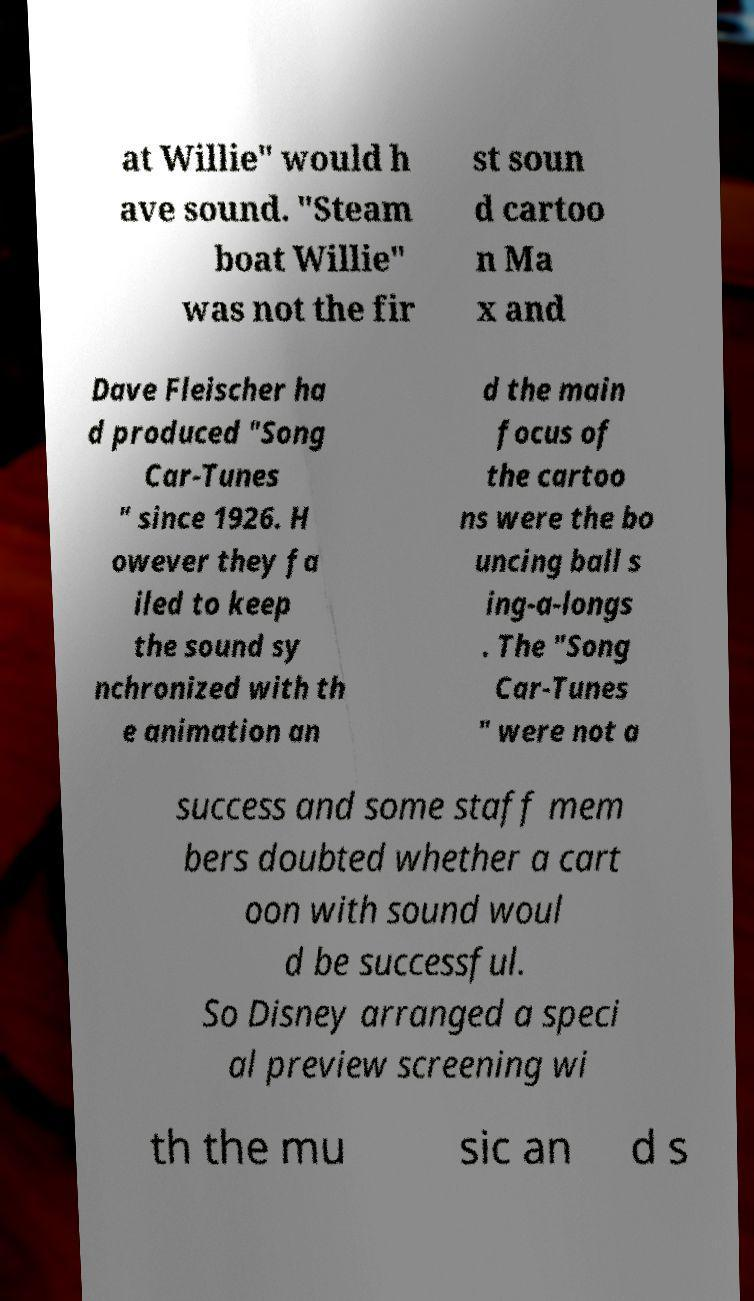Could you extract and type out the text from this image? at Willie" would h ave sound. "Steam boat Willie" was not the fir st soun d cartoo n Ma x and Dave Fleischer ha d produced "Song Car-Tunes " since 1926. H owever they fa iled to keep the sound sy nchronized with th e animation an d the main focus of the cartoo ns were the bo uncing ball s ing-a-longs . The "Song Car-Tunes " were not a success and some staff mem bers doubted whether a cart oon with sound woul d be successful. So Disney arranged a speci al preview screening wi th the mu sic an d s 